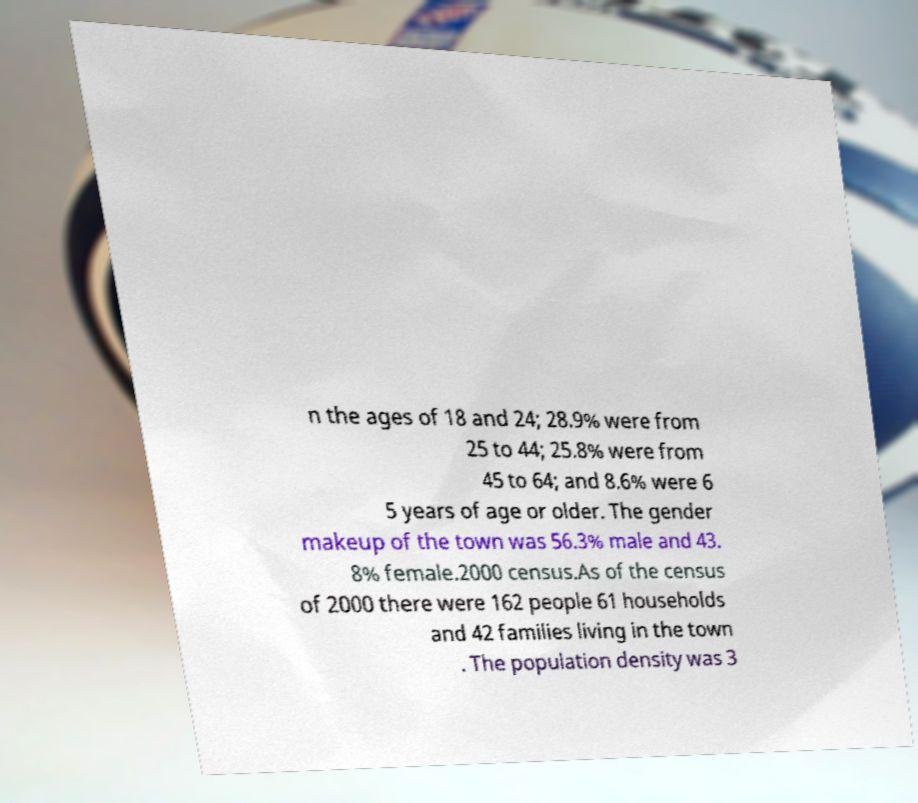What messages or text are displayed in this image? I need them in a readable, typed format. n the ages of 18 and 24; 28.9% were from 25 to 44; 25.8% were from 45 to 64; and 8.6% were 6 5 years of age or older. The gender makeup of the town was 56.3% male and 43. 8% female.2000 census.As of the census of 2000 there were 162 people 61 households and 42 families living in the town . The population density was 3 